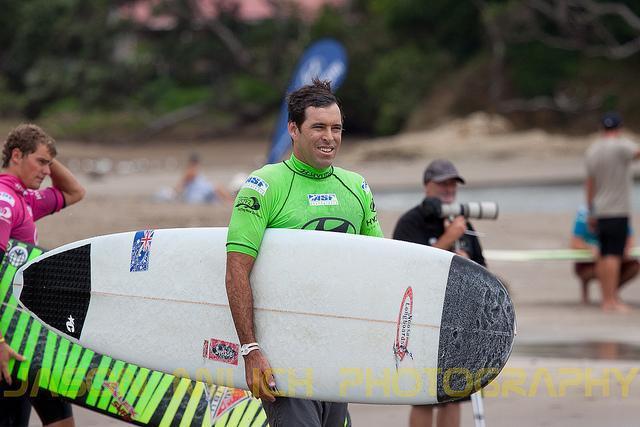How many surfboards are visible?
Give a very brief answer. 2. How many people can be seen?
Give a very brief answer. 5. How many red kites are there?
Give a very brief answer. 0. 